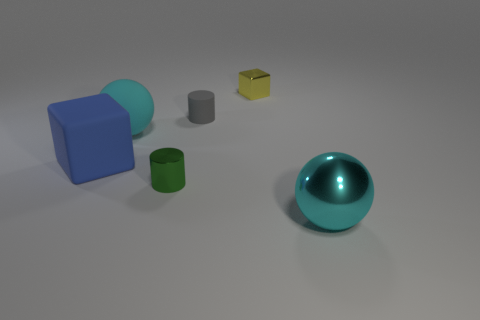Add 3 big blocks. How many objects exist? 9 Subtract all cubes. How many objects are left? 4 Add 5 cyan objects. How many cyan objects are left? 7 Add 5 cubes. How many cubes exist? 7 Subtract 0 purple cylinders. How many objects are left? 6 Subtract all small red cylinders. Subtract all small things. How many objects are left? 3 